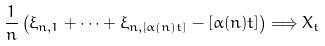Convert formula to latex. <formula><loc_0><loc_0><loc_500><loc_500>\frac { 1 } { n } \left ( \xi _ { n , 1 } + \cdots + \xi _ { n , [ \alpha ( n ) t ] } - [ \alpha ( n ) t ] \right ) \Longrightarrow X _ { t }</formula> 